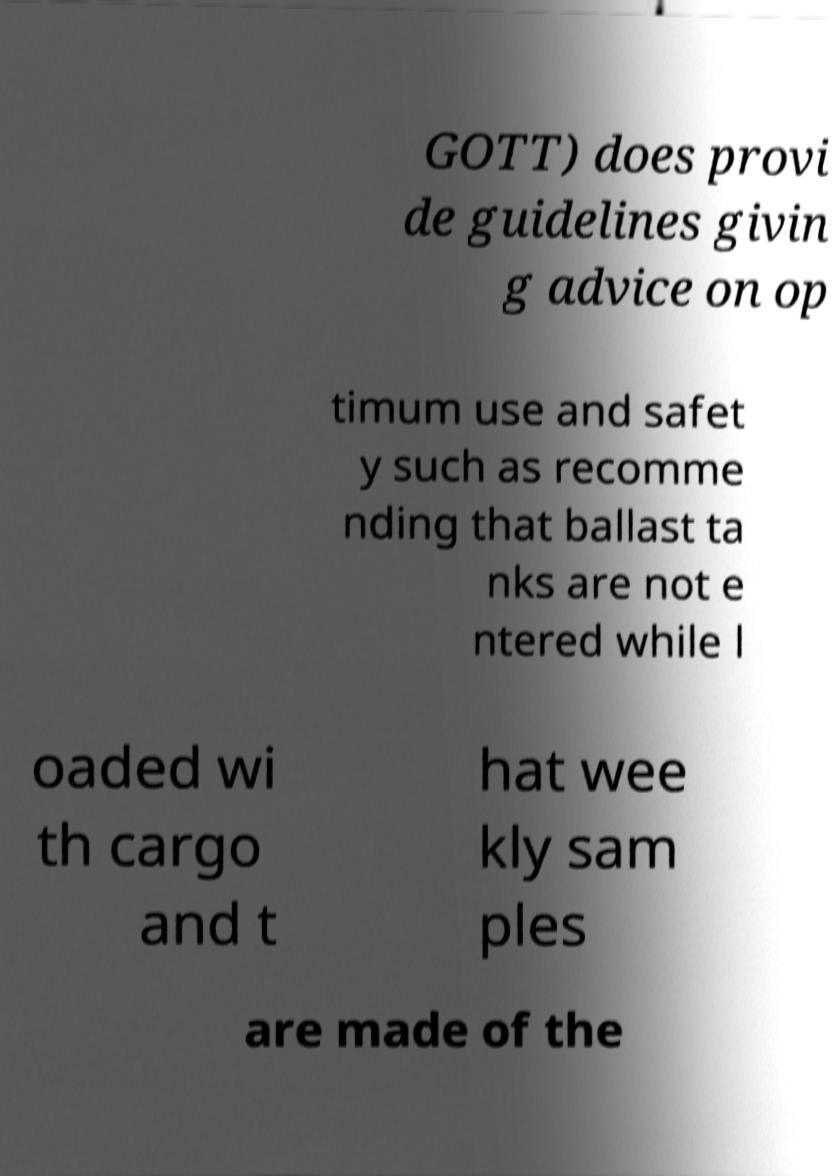There's text embedded in this image that I need extracted. Can you transcribe it verbatim? GOTT) does provi de guidelines givin g advice on op timum use and safet y such as recomme nding that ballast ta nks are not e ntered while l oaded wi th cargo and t hat wee kly sam ples are made of the 